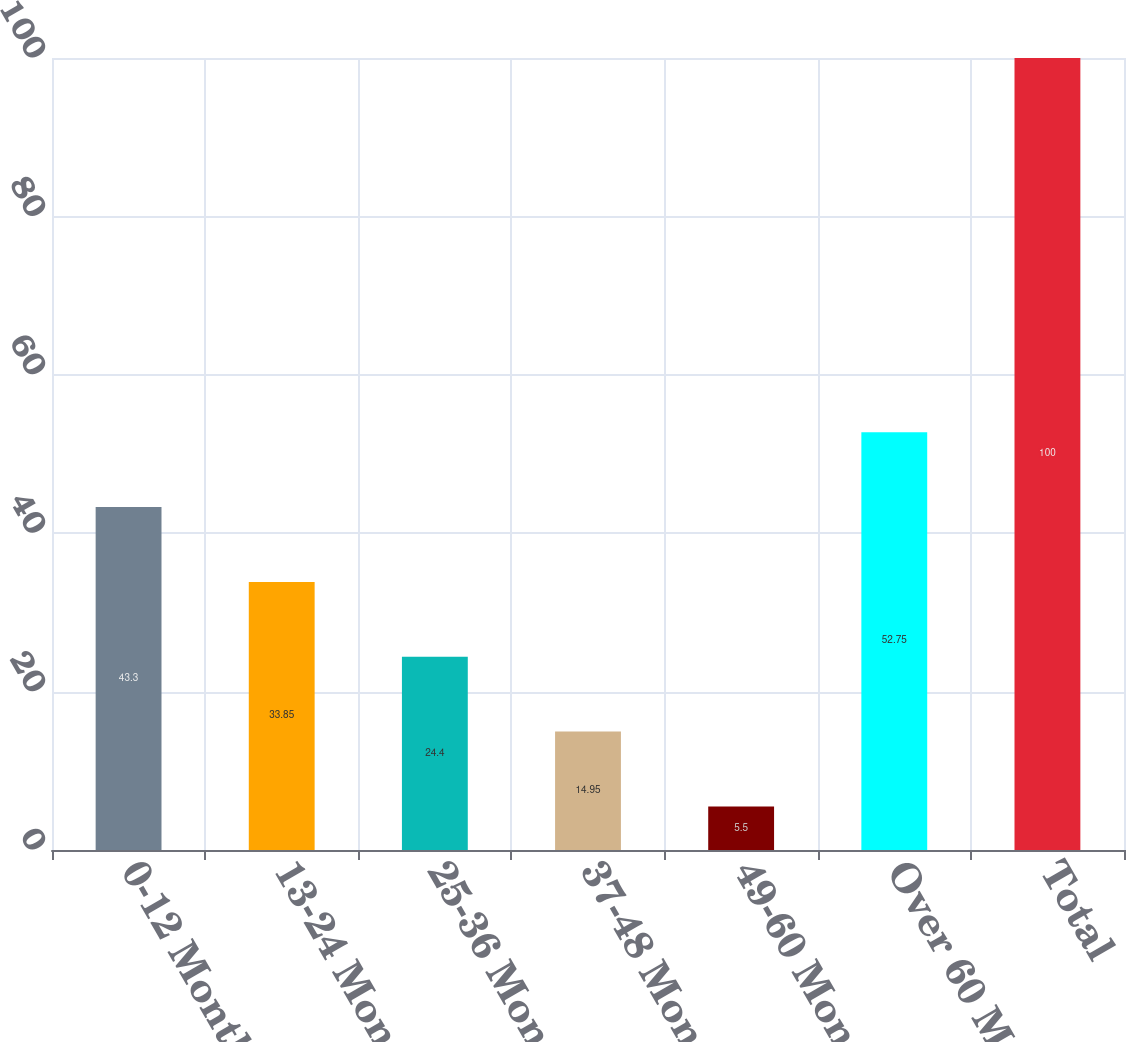Convert chart to OTSL. <chart><loc_0><loc_0><loc_500><loc_500><bar_chart><fcel>0-12 Months<fcel>13-24 Months<fcel>25-36 Months<fcel>37-48 Months<fcel>49-60 Months<fcel>Over 60 Months<fcel>Total<nl><fcel>43.3<fcel>33.85<fcel>24.4<fcel>14.95<fcel>5.5<fcel>52.75<fcel>100<nl></chart> 